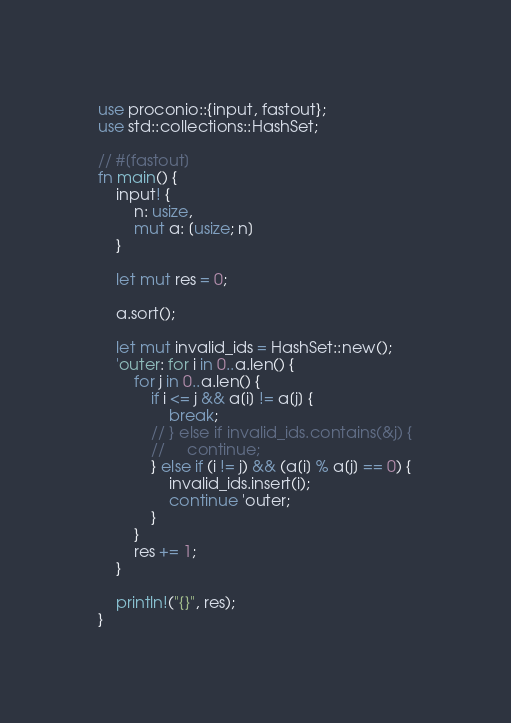<code> <loc_0><loc_0><loc_500><loc_500><_Rust_>use proconio::{input, fastout};
use std::collections::HashSet;

// #[fastout]
fn main() {
    input! {
        n: usize,
        mut a: [usize; n]
    }

    let mut res = 0;

    a.sort();

    let mut invalid_ids = HashSet::new();
    'outer: for i in 0..a.len() {
        for j in 0..a.len() {
            if i <= j && a[i] != a[j] {
                break;
            // } else if invalid_ids.contains(&j) {
            //     continue;
            } else if (i != j) && (a[i] % a[j] == 0) {
                invalid_ids.insert(i);
                continue 'outer;
            }
        }
        res += 1;
    }

    println!("{}", res);
}
</code> 